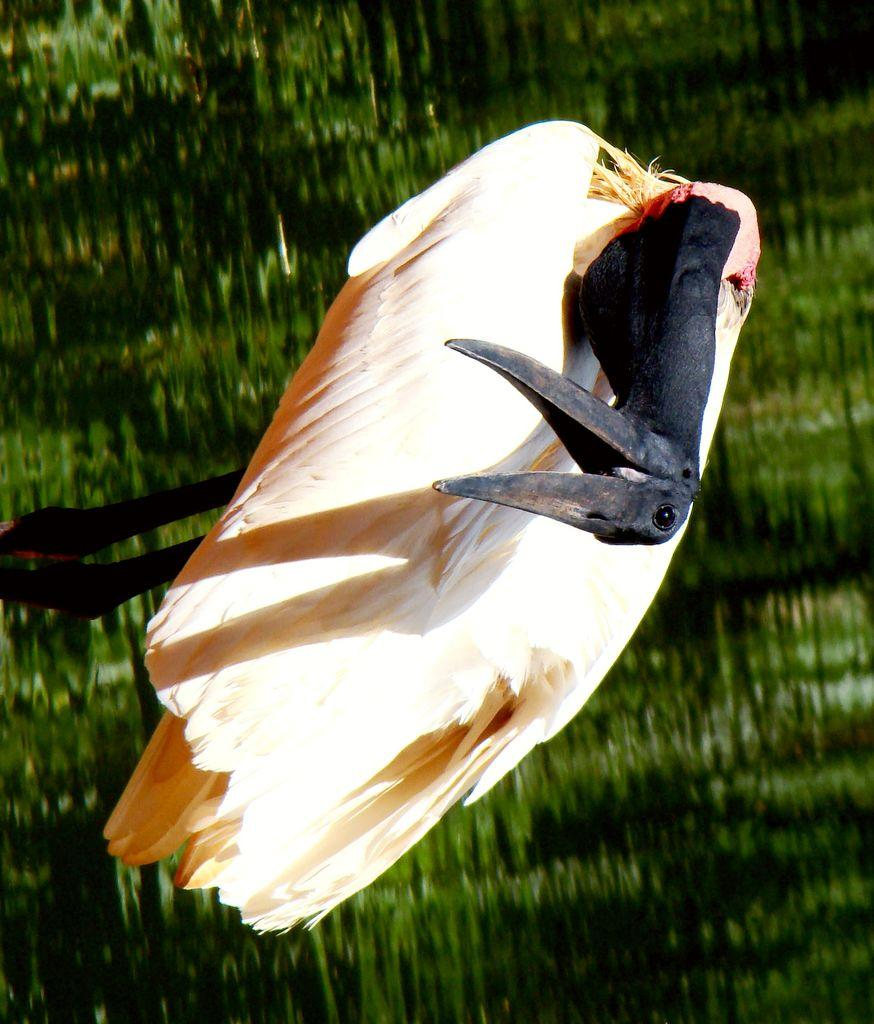What type of animal can be seen in the image? There is a bird in the image. Where is the bird located in the image? The bird is on the ground. What type of slope can be seen in the bird's face in the image? There is no slope visible in the bird's face in the image, nor is there any reference to a slope in the provided facts. 